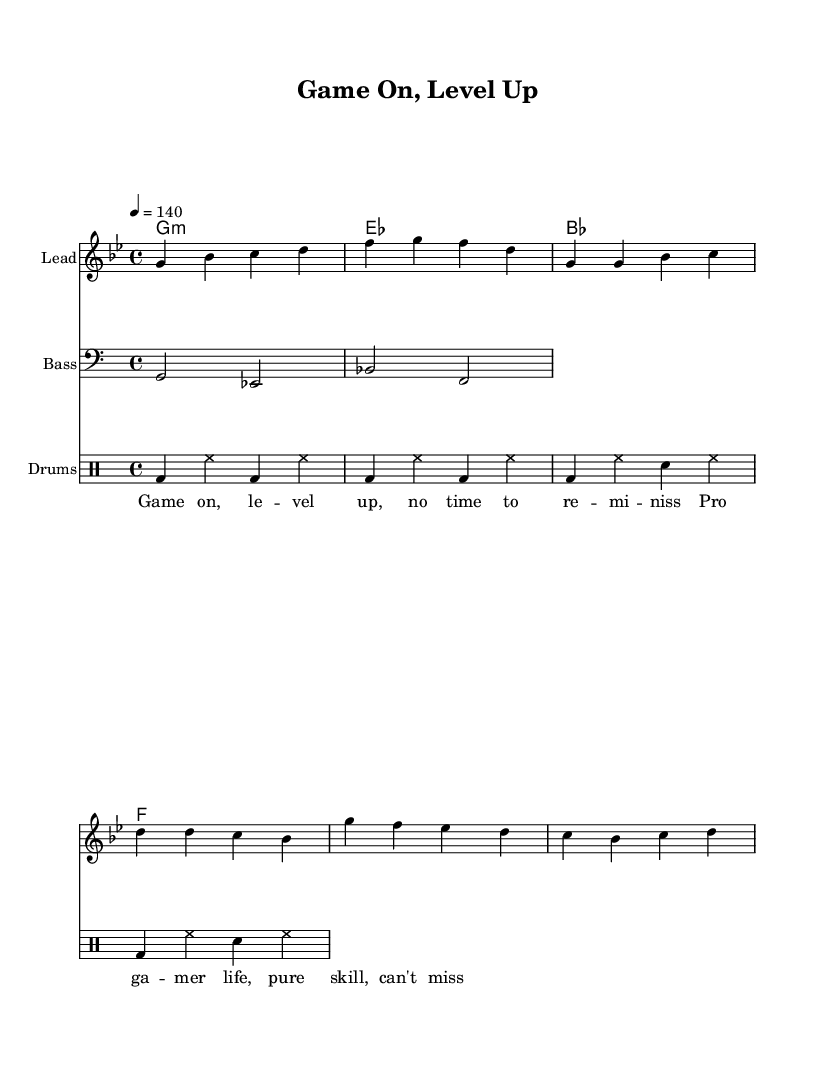What is the key signature of this music? The key signature is indicated at the beginning of the sheet music and shows that there are two flats, indicating the key is G minor.
Answer: G minor What is the time signature of this piece? The time signature is displayed at the beginning of the sheet music and shows a 4/4 signature, meaning each measure contains four beats.
Answer: 4/4 What is the tempo marking for this piece? The tempo marking is indicated in the global context, showing a speed of 140 beats per minute, which dictates how fast the piece should be played.
Answer: 140 How many measures are in the melody section? By counting the measures in the melody part, it can be seen that there are a total of eight measures in the melody section.
Answer: 8 What type of music genre does this sheet music represent? The overall structure, lyrics, and rhythmic elements point towards the rap genre, which is characterized by its rhythm and strong lyrical flow.
Answer: Rap What is the first lyric line of the song? The lyrics are situated below the melody and the first line reads "Game on, level up, no time to re-miniss." This line sets the competitive tone of the song.
Answer: Game on, level up, no time to re-miniss What instruments are included in this score? The score lists a lead instrument (melody), a bass instrument, and a drum part, which are typical for an energetic rap arrangement focusing on beats and rhythm.
Answer: Lead, Bass, Drums 